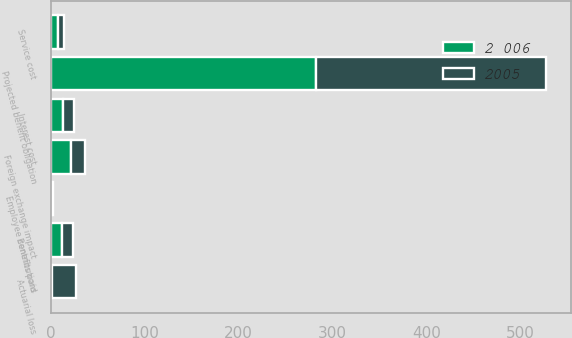Convert chart to OTSL. <chart><loc_0><loc_0><loc_500><loc_500><stacked_bar_chart><ecel><fcel>Projected benefit obligation<fcel>Service cost<fcel>Interest cost<fcel>Actuarial loss<fcel>Benefits paid<fcel>Employee contributions<fcel>Foreign exchange impact<nl><fcel>2 006<fcel>283<fcel>7.9<fcel>13.2<fcel>1.8<fcel>12.5<fcel>1.4<fcel>21.5<nl><fcel>2005<fcel>244.9<fcel>6.8<fcel>11.8<fcel>25<fcel>11.1<fcel>1<fcel>15.1<nl></chart> 